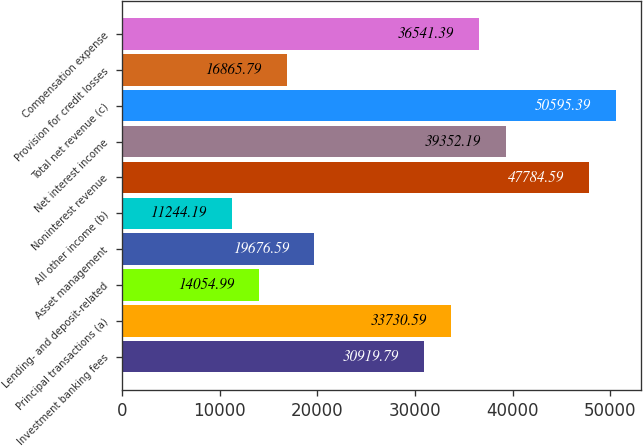Convert chart to OTSL. <chart><loc_0><loc_0><loc_500><loc_500><bar_chart><fcel>Investment banking fees<fcel>Principal transactions (a)<fcel>Lending- and deposit-related<fcel>Asset management<fcel>All other income (b)<fcel>Noninterest revenue<fcel>Net interest income<fcel>Total net revenue (c)<fcel>Provision for credit losses<fcel>Compensation expense<nl><fcel>30919.8<fcel>33730.6<fcel>14055<fcel>19676.6<fcel>11244.2<fcel>47784.6<fcel>39352.2<fcel>50595.4<fcel>16865.8<fcel>36541.4<nl></chart> 